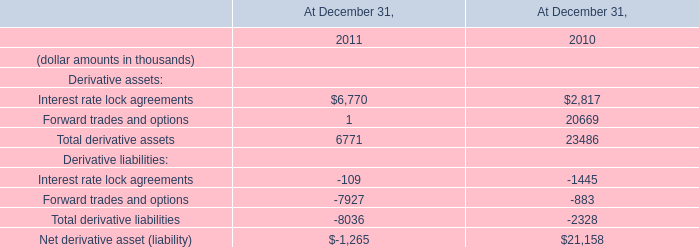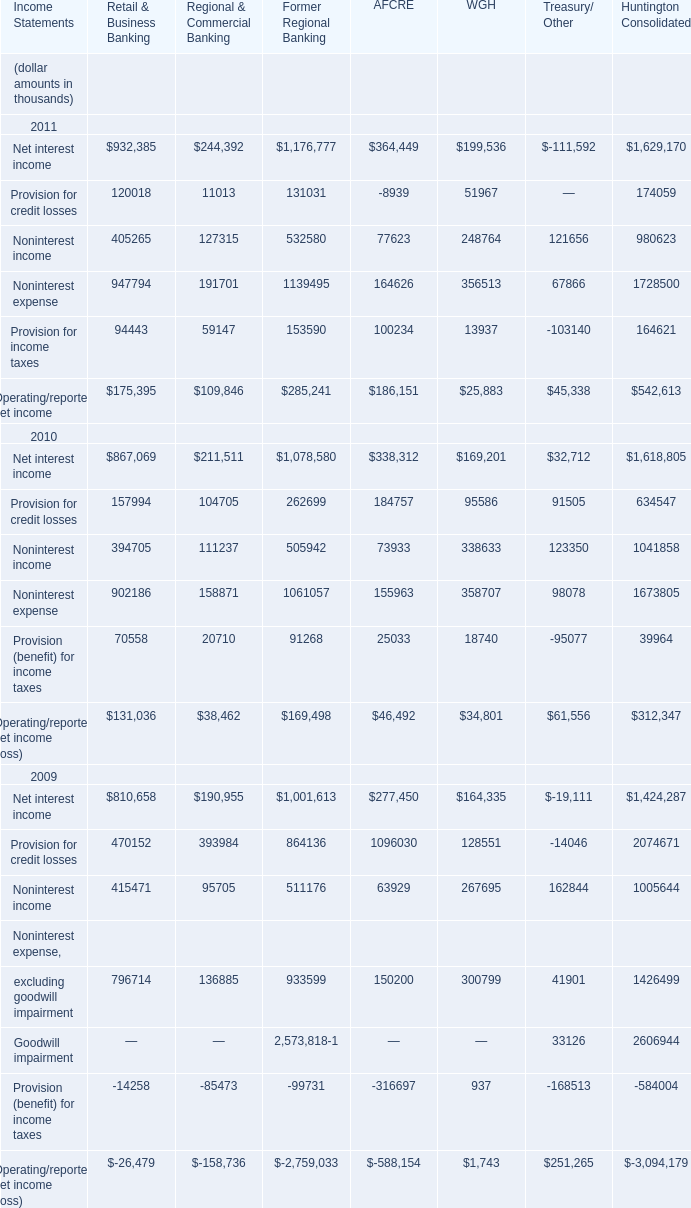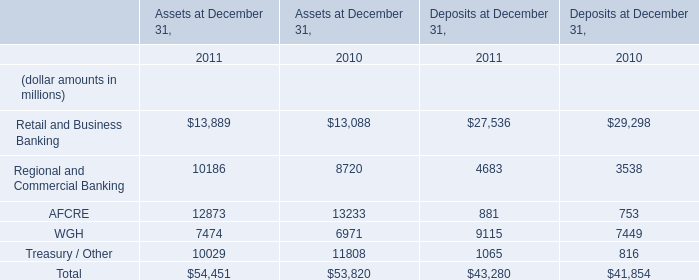What's the increasing rate of WGH in Assets at December 31,2011? (in %) 
Computations: ((7474 - 6971) / 6971)
Answer: 0.07216. 